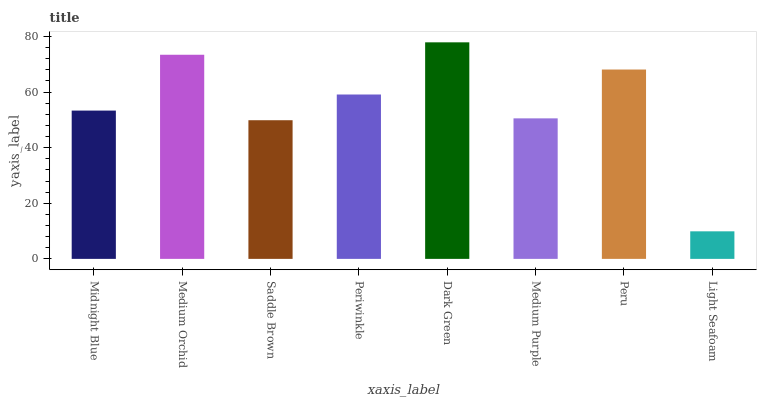Is Light Seafoam the minimum?
Answer yes or no. Yes. Is Dark Green the maximum?
Answer yes or no. Yes. Is Medium Orchid the minimum?
Answer yes or no. No. Is Medium Orchid the maximum?
Answer yes or no. No. Is Medium Orchid greater than Midnight Blue?
Answer yes or no. Yes. Is Midnight Blue less than Medium Orchid?
Answer yes or no. Yes. Is Midnight Blue greater than Medium Orchid?
Answer yes or no. No. Is Medium Orchid less than Midnight Blue?
Answer yes or no. No. Is Periwinkle the high median?
Answer yes or no. Yes. Is Midnight Blue the low median?
Answer yes or no. Yes. Is Dark Green the high median?
Answer yes or no. No. Is Periwinkle the low median?
Answer yes or no. No. 